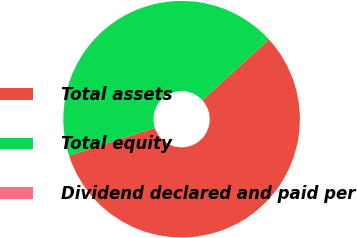<chart> <loc_0><loc_0><loc_500><loc_500><pie_chart><fcel>Total assets<fcel>Total equity<fcel>Dividend declared and paid per<nl><fcel>56.8%<fcel>43.2%<fcel>0.0%<nl></chart> 